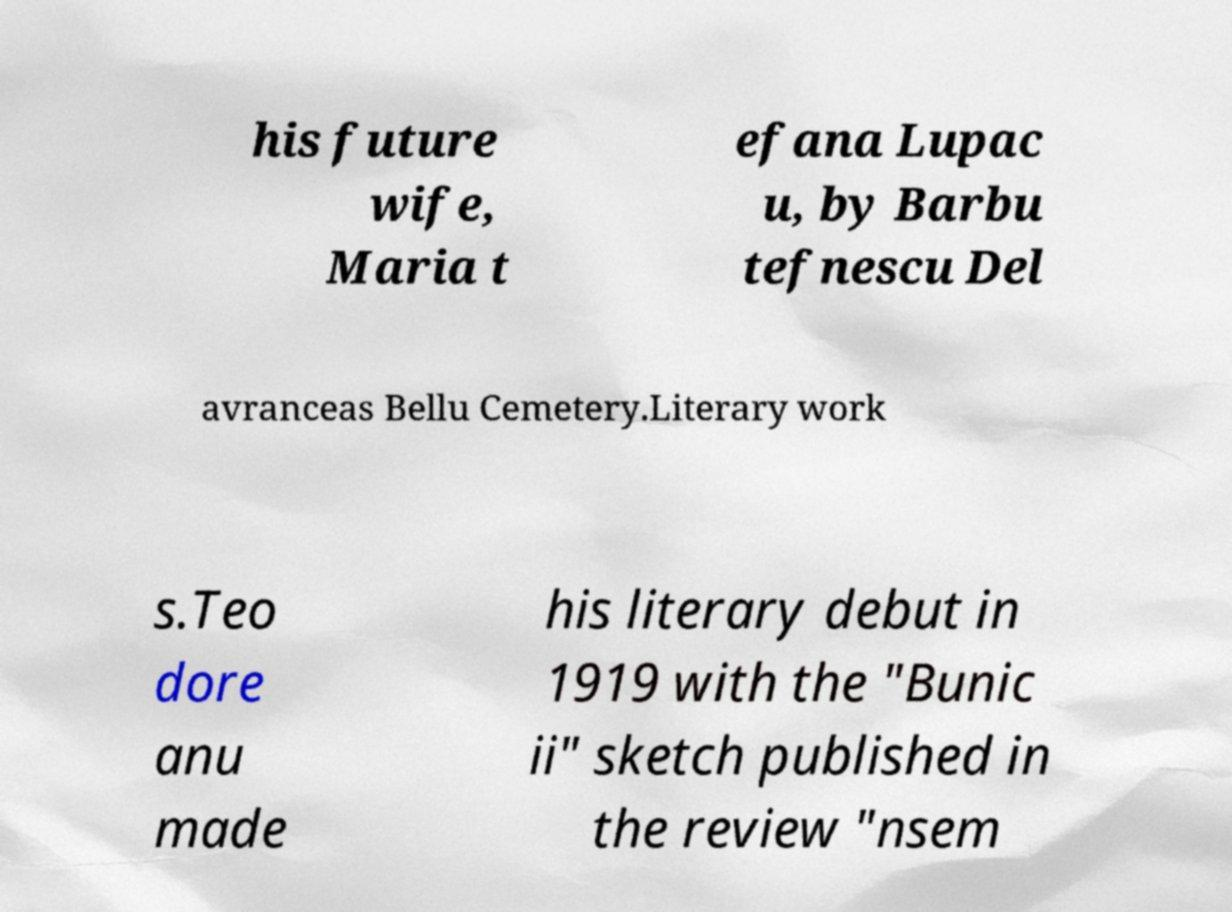Can you read and provide the text displayed in the image?This photo seems to have some interesting text. Can you extract and type it out for me? his future wife, Maria t efana Lupac u, by Barbu tefnescu Del avranceas Bellu Cemetery.Literary work s.Teo dore anu made his literary debut in 1919 with the "Bunic ii" sketch published in the review "nsem 